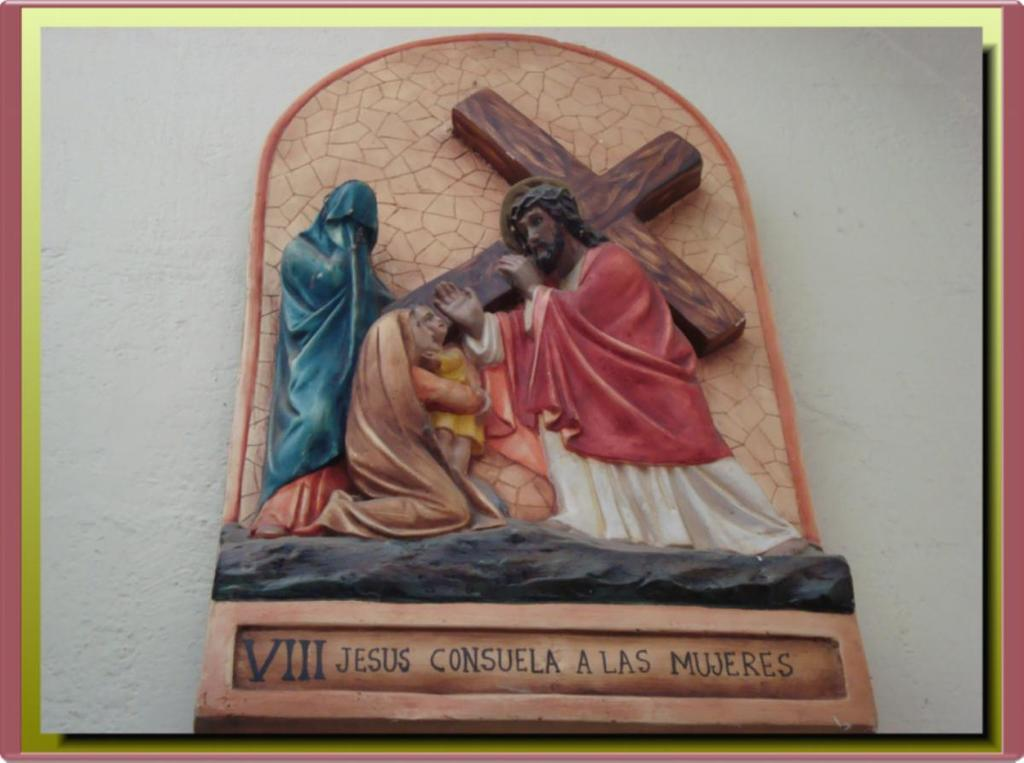<image>
Write a terse but informative summary of the picture. The words Jesus Consuela A Las Mujeres is written at the bottom of the plaque. 